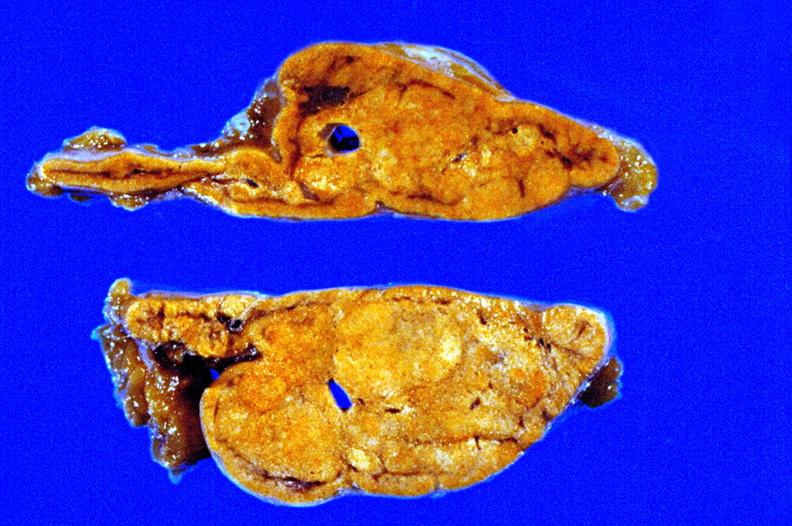what is present?
Answer the question using a single word or phrase. Endocrine 